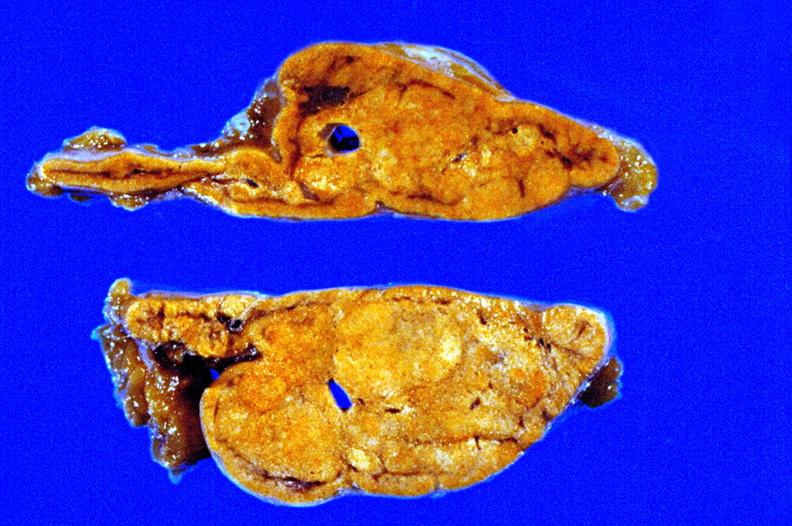what is present?
Answer the question using a single word or phrase. Endocrine 